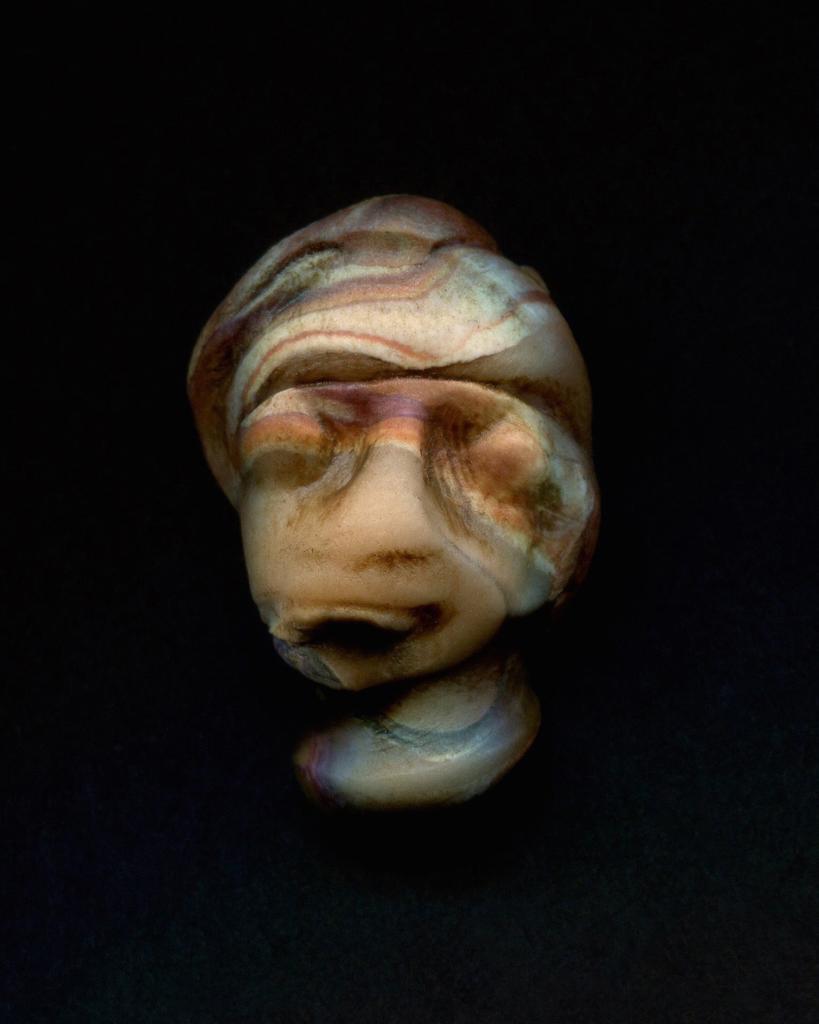In one or two sentences, can you explain what this image depicts? In the image there is a sculpture with colorful paints on it and the background is black. 